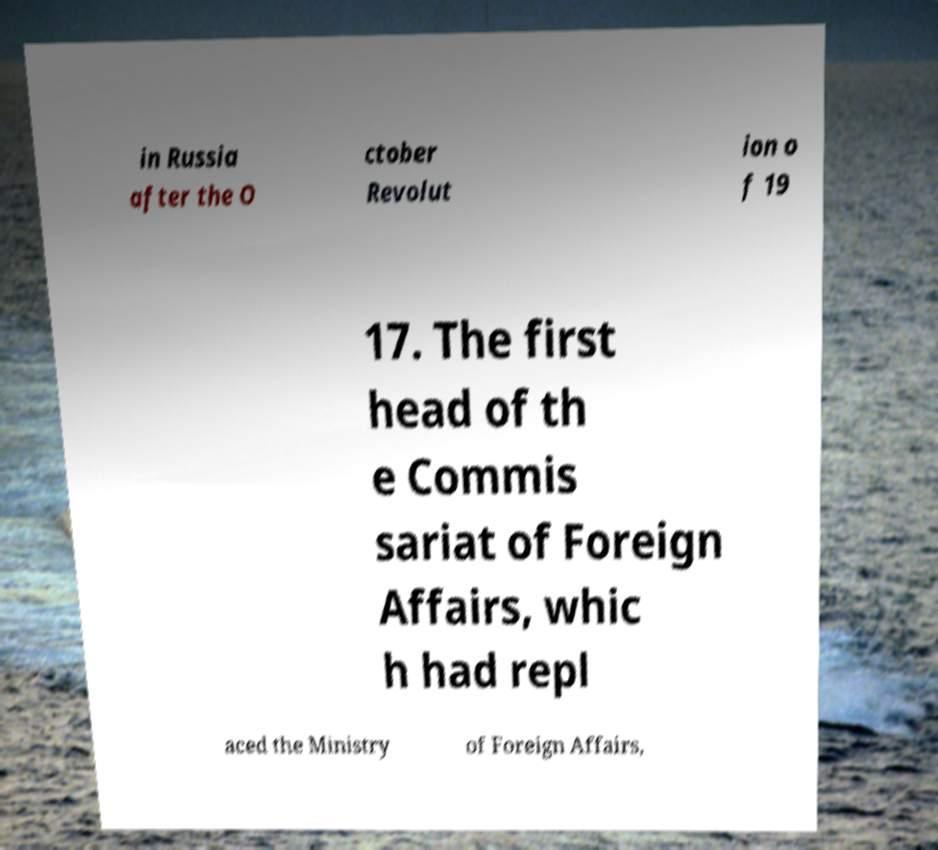For documentation purposes, I need the text within this image transcribed. Could you provide that? in Russia after the O ctober Revolut ion o f 19 17. The first head of th e Commis sariat of Foreign Affairs, whic h had repl aced the Ministry of Foreign Affairs, 